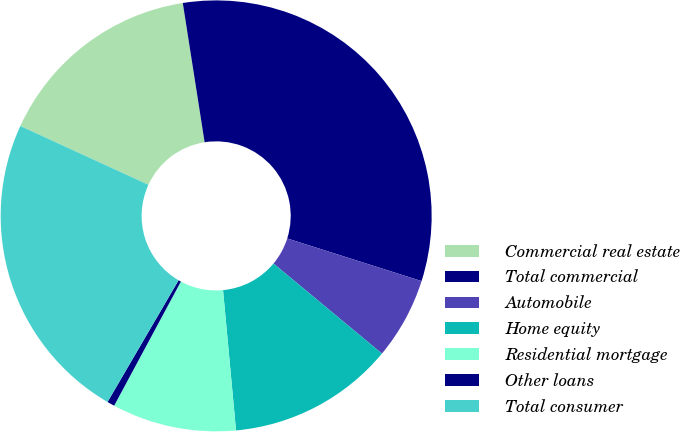Convert chart. <chart><loc_0><loc_0><loc_500><loc_500><pie_chart><fcel>Commercial real estate<fcel>Total commercial<fcel>Automobile<fcel>Home equity<fcel>Residential mortgage<fcel>Other loans<fcel>Total consumer<nl><fcel>15.68%<fcel>32.37%<fcel>6.14%<fcel>12.5%<fcel>9.32%<fcel>0.56%<fcel>23.44%<nl></chart> 